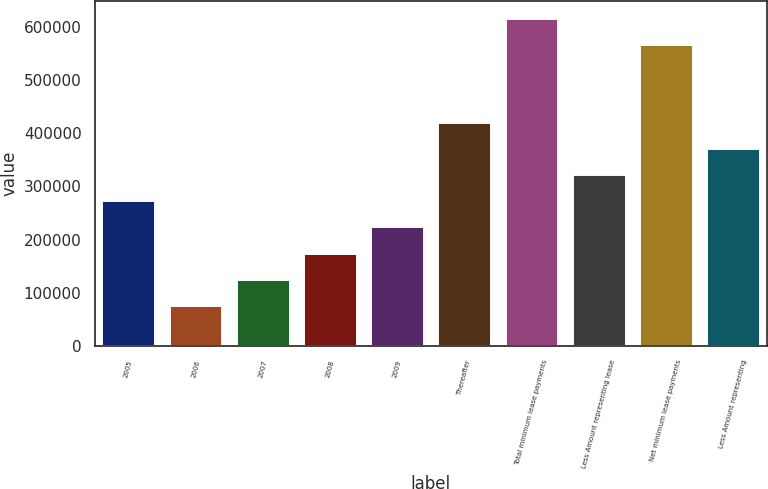Convert chart to OTSL. <chart><loc_0><loc_0><loc_500><loc_500><bar_chart><fcel>2005<fcel>2006<fcel>2007<fcel>2008<fcel>2009<fcel>Thereafter<fcel>Total minimum lease payments<fcel>Less Amount representing lease<fcel>Net minimum lease payments<fcel>Less Amount representing<nl><fcel>273860<fcel>77542.3<fcel>126622<fcel>175701<fcel>224780<fcel>421097<fcel>617415<fcel>322939<fcel>568335<fcel>372018<nl></chart> 